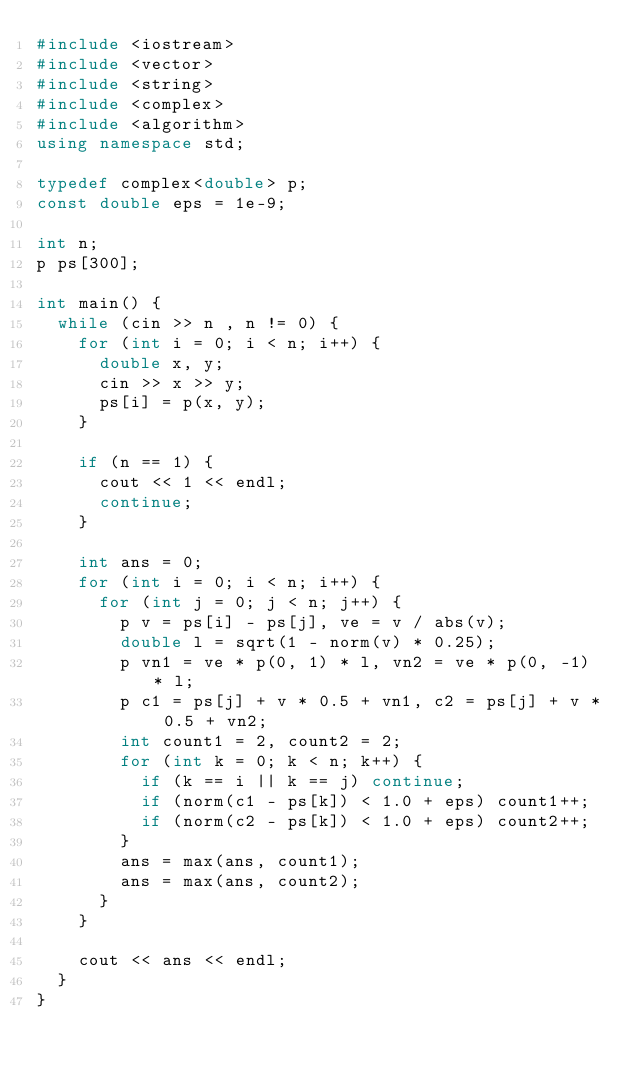Convert code to text. <code><loc_0><loc_0><loc_500><loc_500><_C++_>#include <iostream>
#include <vector>
#include <string>
#include <complex>
#include <algorithm>
using namespace std;

typedef complex<double> p;
const double eps = 1e-9;

int n;
p ps[300];

int main() {
	while (cin >> n , n != 0) {
		for (int i = 0; i < n; i++) {
			double x, y;
			cin >> x >> y;
			ps[i] = p(x, y);
		}

		if (n == 1) {
			cout << 1 << endl;
			continue;
		}

		int ans = 0;
		for (int i = 0; i < n; i++) {
			for (int j = 0; j < n; j++) {
				p v = ps[i] - ps[j], ve = v / abs(v);
				double l = sqrt(1 - norm(v) * 0.25);
				p vn1 = ve * p(0, 1) * l, vn2 = ve * p(0, -1) * l;
				p c1 = ps[j] + v * 0.5 + vn1, c2 = ps[j] + v * 0.5 + vn2;
				int count1 = 2, count2 = 2;
				for (int k = 0; k < n; k++) {
					if (k == i || k == j) continue;
					if (norm(c1 - ps[k]) < 1.0 + eps) count1++;
					if (norm(c2 - ps[k]) < 1.0 + eps) count2++;
				}
				ans = max(ans, count1);
				ans = max(ans, count2);
			}
		}

		cout << ans << endl;
	}
}</code> 